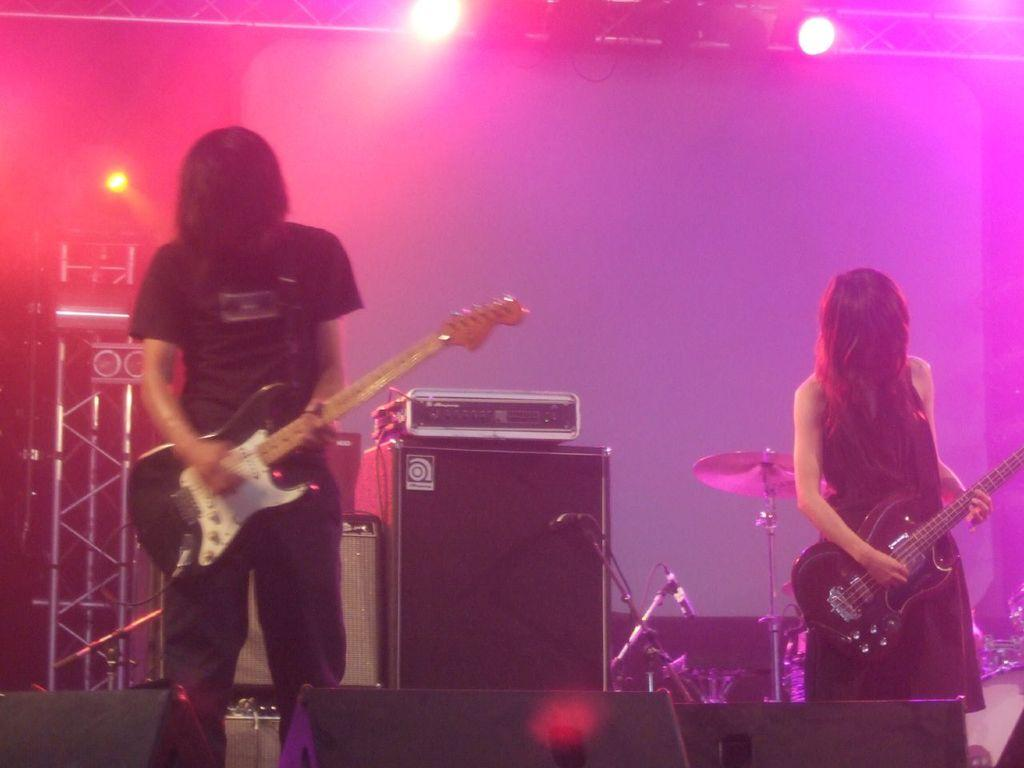How many people are in the image? There are two persons in the image. What are the two persons doing in the image? The two persons are playing the guitar. Where are the two persons located in the image? The two persons are on a stage. What else can be seen in the image besides the two persons? There are many instruments in the image. What color are the two persons wearing? Both persons are wearing black. What is the lighting condition in the image? The background of the image is dark. What type of stem is visible in the image? There is no stem present in the image. Is there a jail visible in the image? No, there is no jail present in the image. 